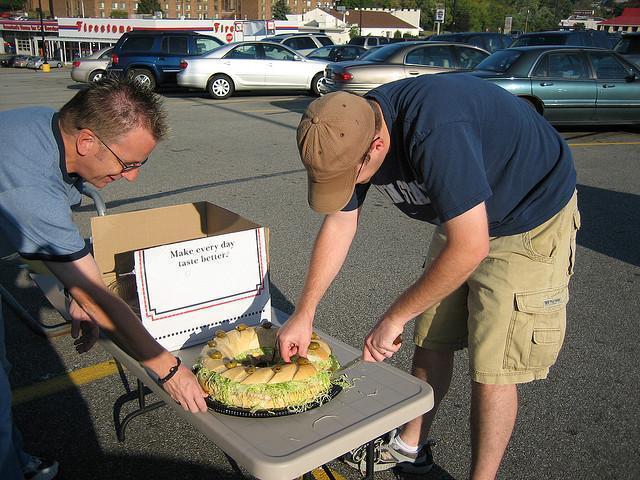How many days ago was this cake made?
From the following set of four choices, select the accurate answer to respond to the question.
Options: One day, today, three days, two days. Today. 